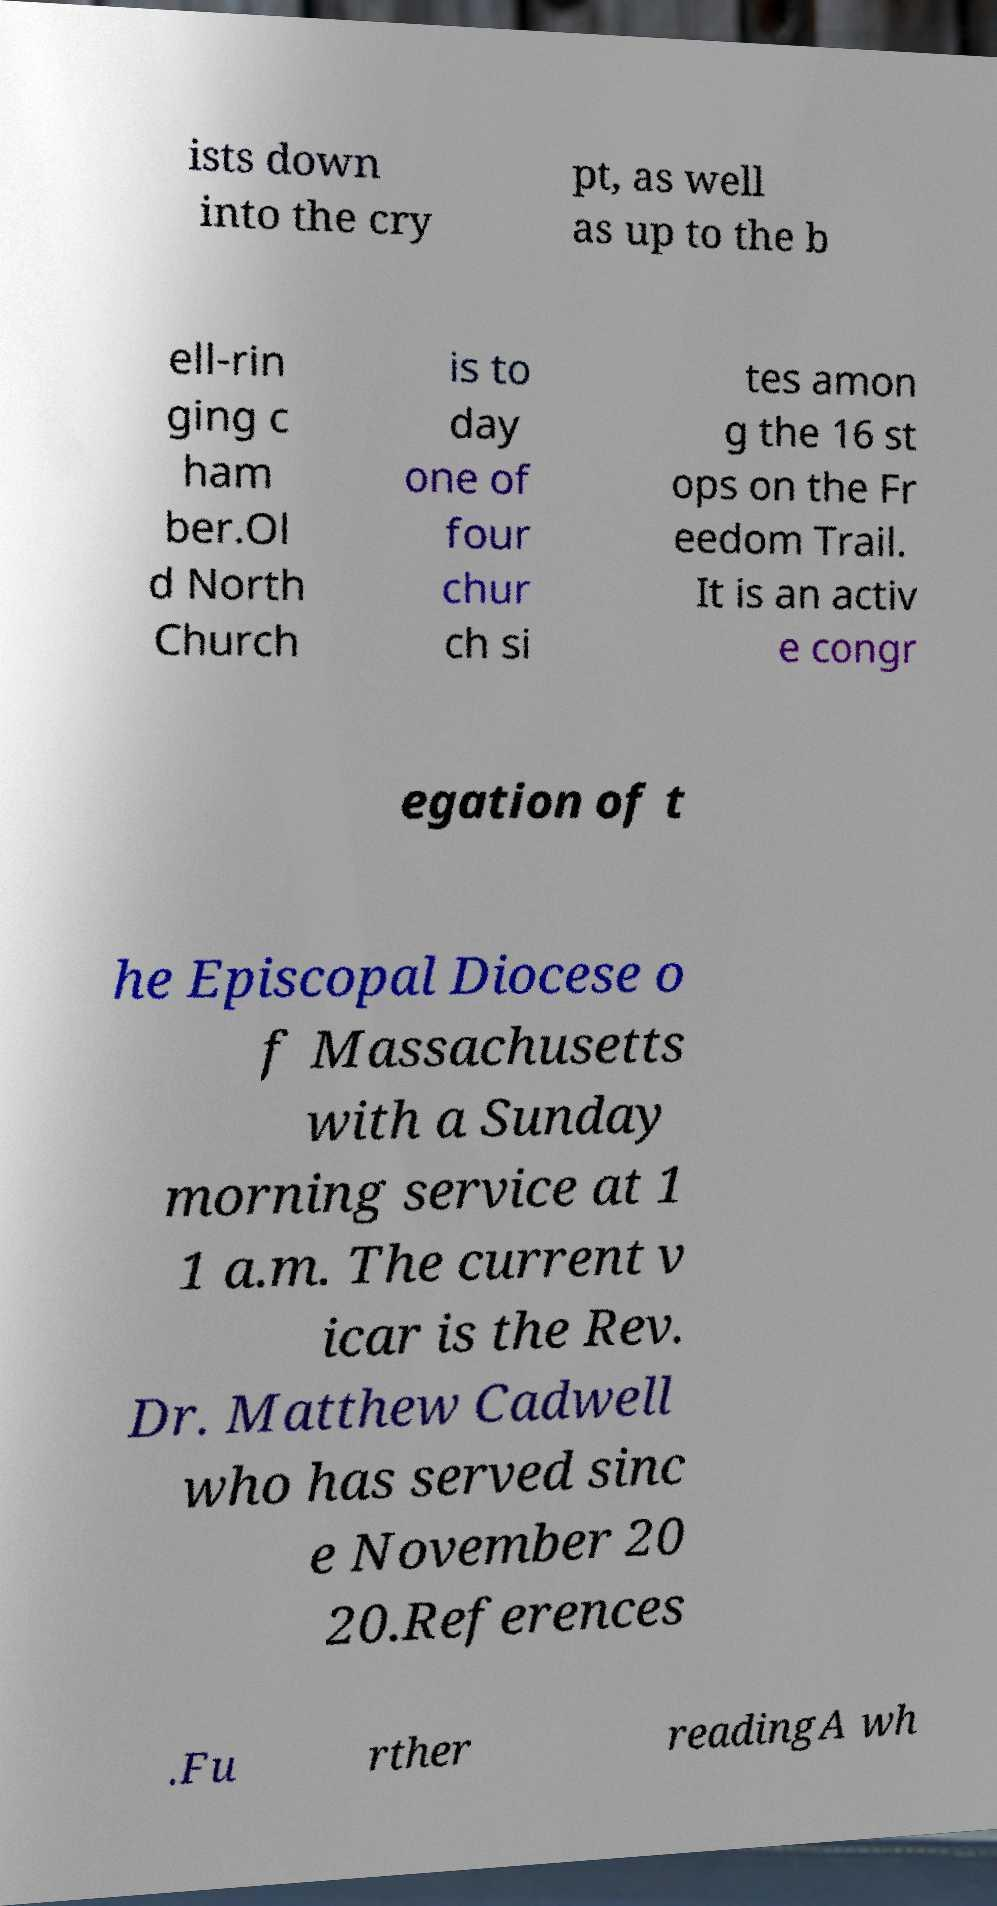I need the written content from this picture converted into text. Can you do that? ists down into the cry pt, as well as up to the b ell-rin ging c ham ber.Ol d North Church is to day one of four chur ch si tes amon g the 16 st ops on the Fr eedom Trail. It is an activ e congr egation of t he Episcopal Diocese o f Massachusetts with a Sunday morning service at 1 1 a.m. The current v icar is the Rev. Dr. Matthew Cadwell who has served sinc e November 20 20.References .Fu rther readingA wh 